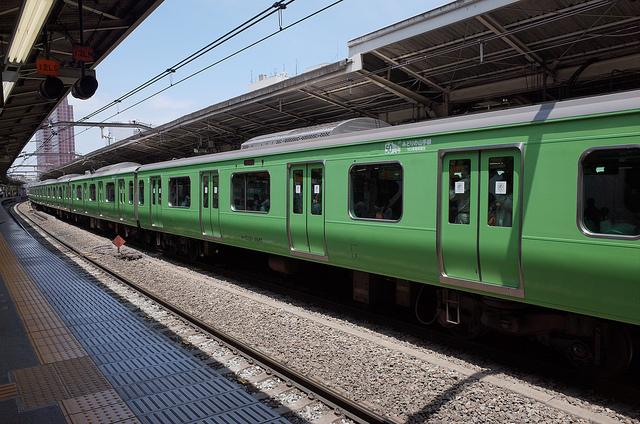Are people getting on and off the train?
Keep it brief. No. Are the doors of the train closed?
Write a very short answer. Yes. What color is the train?
Give a very brief answer. Green. Do you see people standing in the train?
Answer briefly. No. Is the train silver?
Be succinct. No. Are there multiple red train cars?
Keep it brief. No. What is the main color of this train?
Keep it brief. Green. 